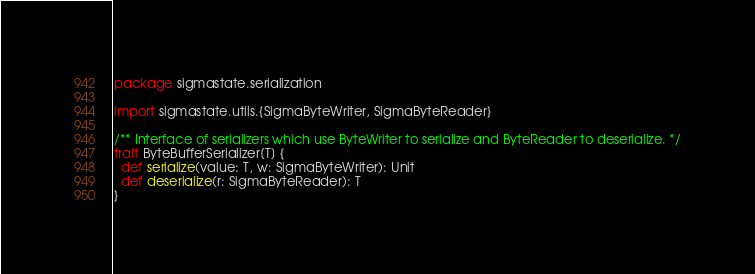Convert code to text. <code><loc_0><loc_0><loc_500><loc_500><_Scala_>package sigmastate.serialization

import sigmastate.utils.{SigmaByteWriter, SigmaByteReader}

/** Interface of serializers which use ByteWriter to serialize and ByteReader to deserialize. */
trait ByteBufferSerializer[T] {
  def serialize(value: T, w: SigmaByteWriter): Unit
  def deserialize(r: SigmaByteReader): T
}
</code> 